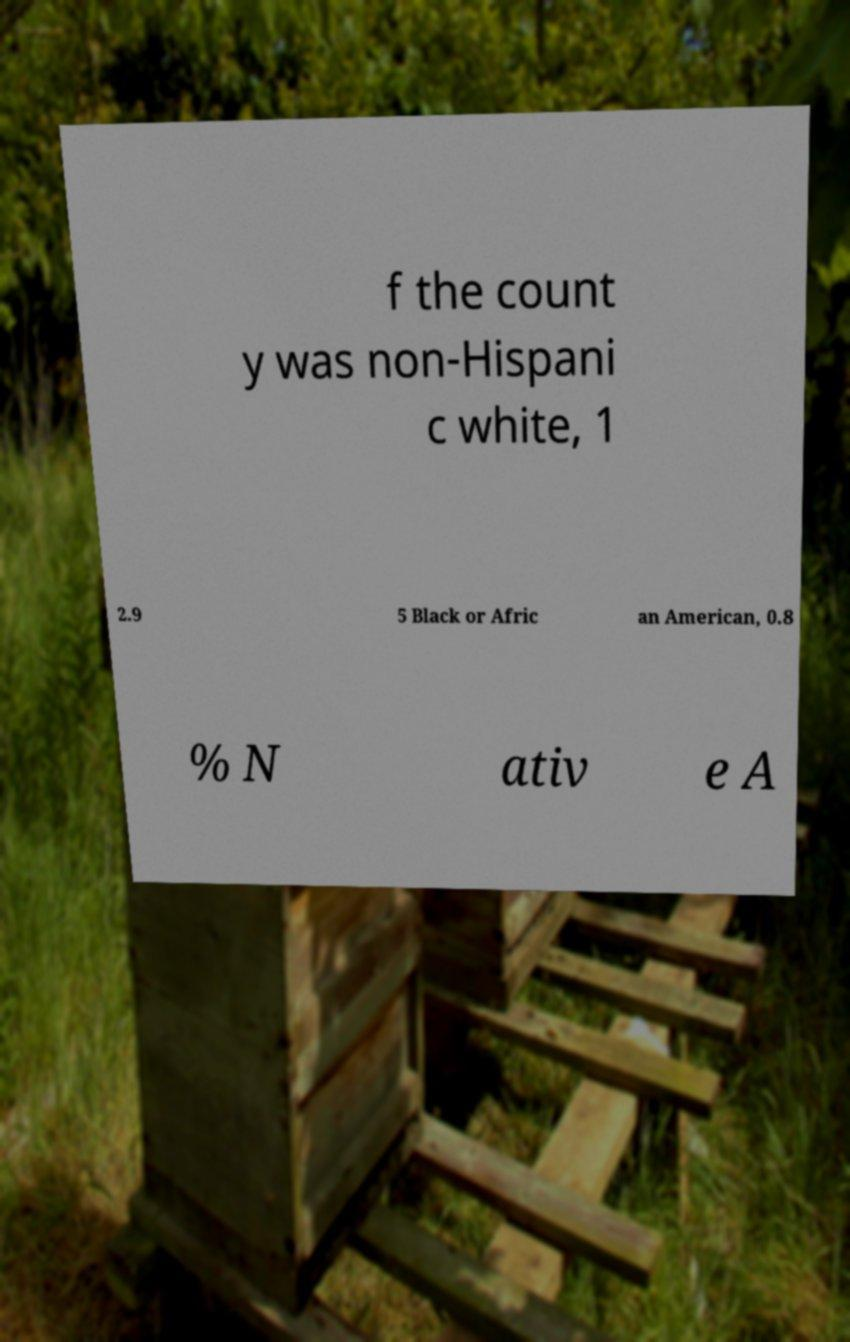What messages or text are displayed in this image? I need them in a readable, typed format. f the count y was non-Hispani c white, 1 2.9 5 Black or Afric an American, 0.8 % N ativ e A 